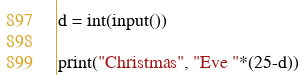<code> <loc_0><loc_0><loc_500><loc_500><_Python_>d = int(input())

print("Christmas", "Eve "*(25-d))
</code> 